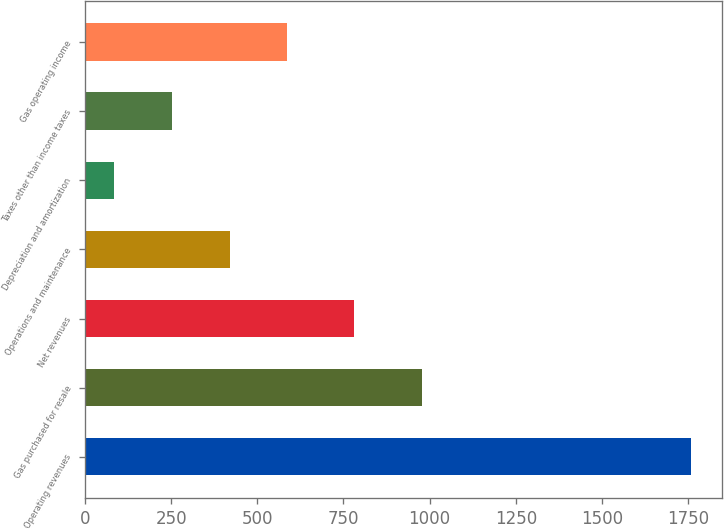Convert chart to OTSL. <chart><loc_0><loc_0><loc_500><loc_500><bar_chart><fcel>Operating revenues<fcel>Gas purchased for resale<fcel>Net revenues<fcel>Operations and maintenance<fcel>Depreciation and amortization<fcel>Taxes other than income taxes<fcel>Gas operating income<nl><fcel>1759<fcel>978<fcel>781<fcel>419.8<fcel>85<fcel>252.4<fcel>587.2<nl></chart> 